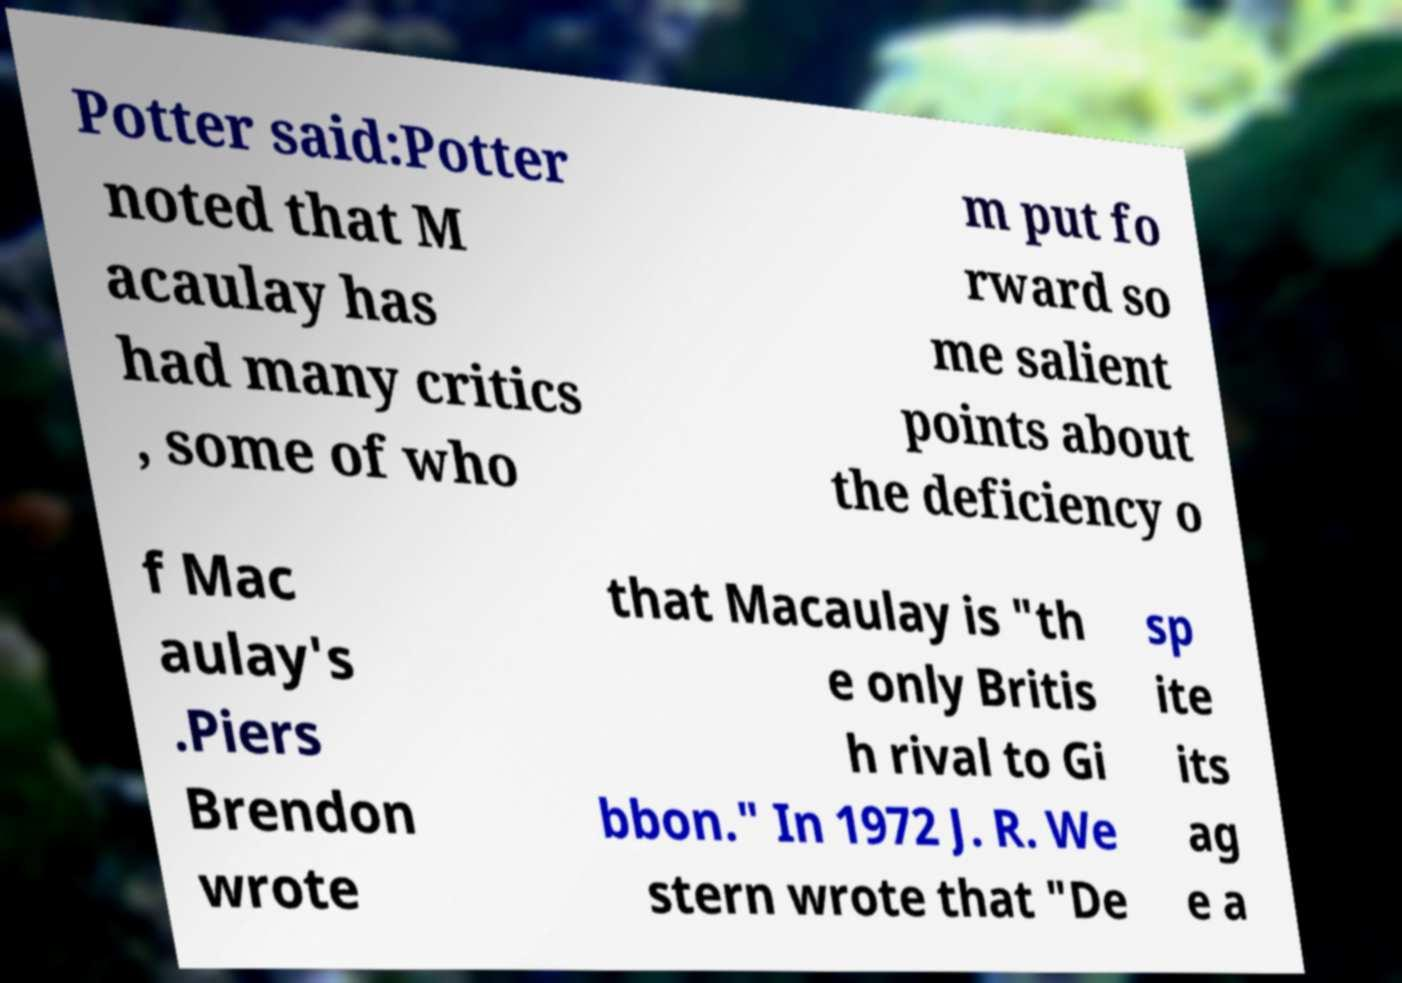Can you accurately transcribe the text from the provided image for me? Potter said:Potter noted that M acaulay has had many critics , some of who m put fo rward so me salient points about the deficiency o f Mac aulay's .Piers Brendon wrote that Macaulay is "th e only Britis h rival to Gi bbon." In 1972 J. R. We stern wrote that "De sp ite its ag e a 